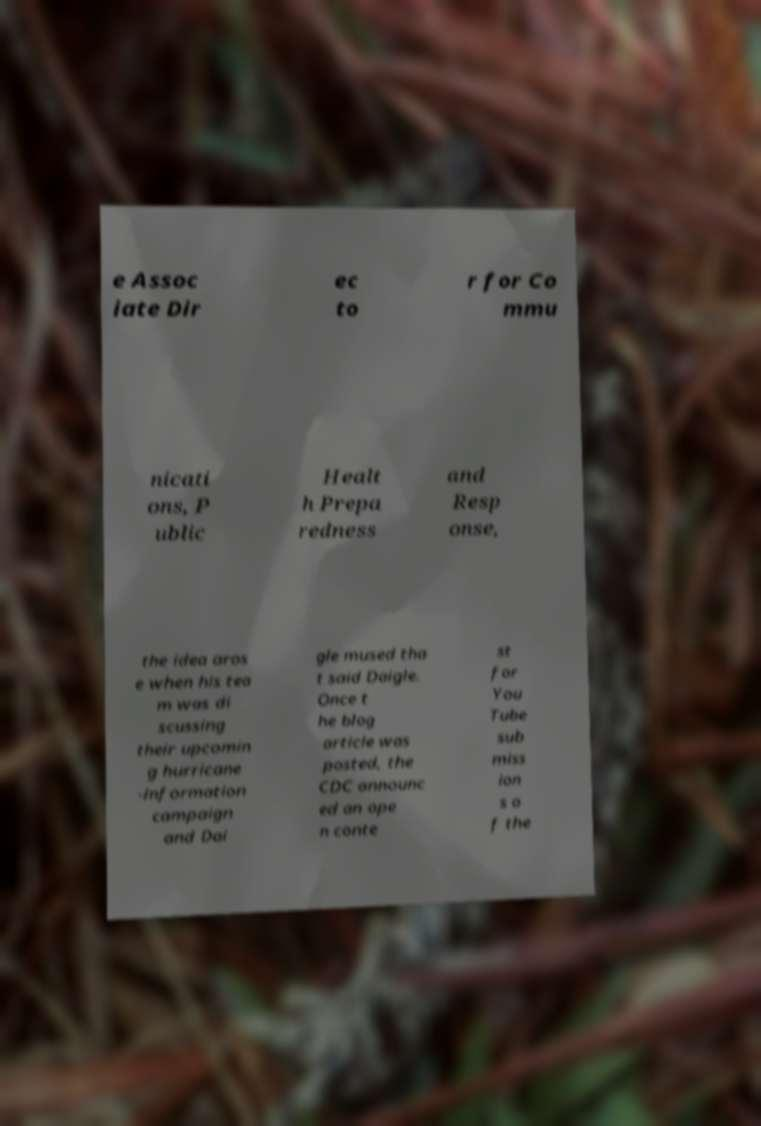Could you extract and type out the text from this image? e Assoc iate Dir ec to r for Co mmu nicati ons, P ublic Healt h Prepa redness and Resp onse, the idea aros e when his tea m was di scussing their upcomin g hurricane -information campaign and Dai gle mused tha t said Daigle. Once t he blog article was posted, the CDC announc ed an ope n conte st for You Tube sub miss ion s o f the 